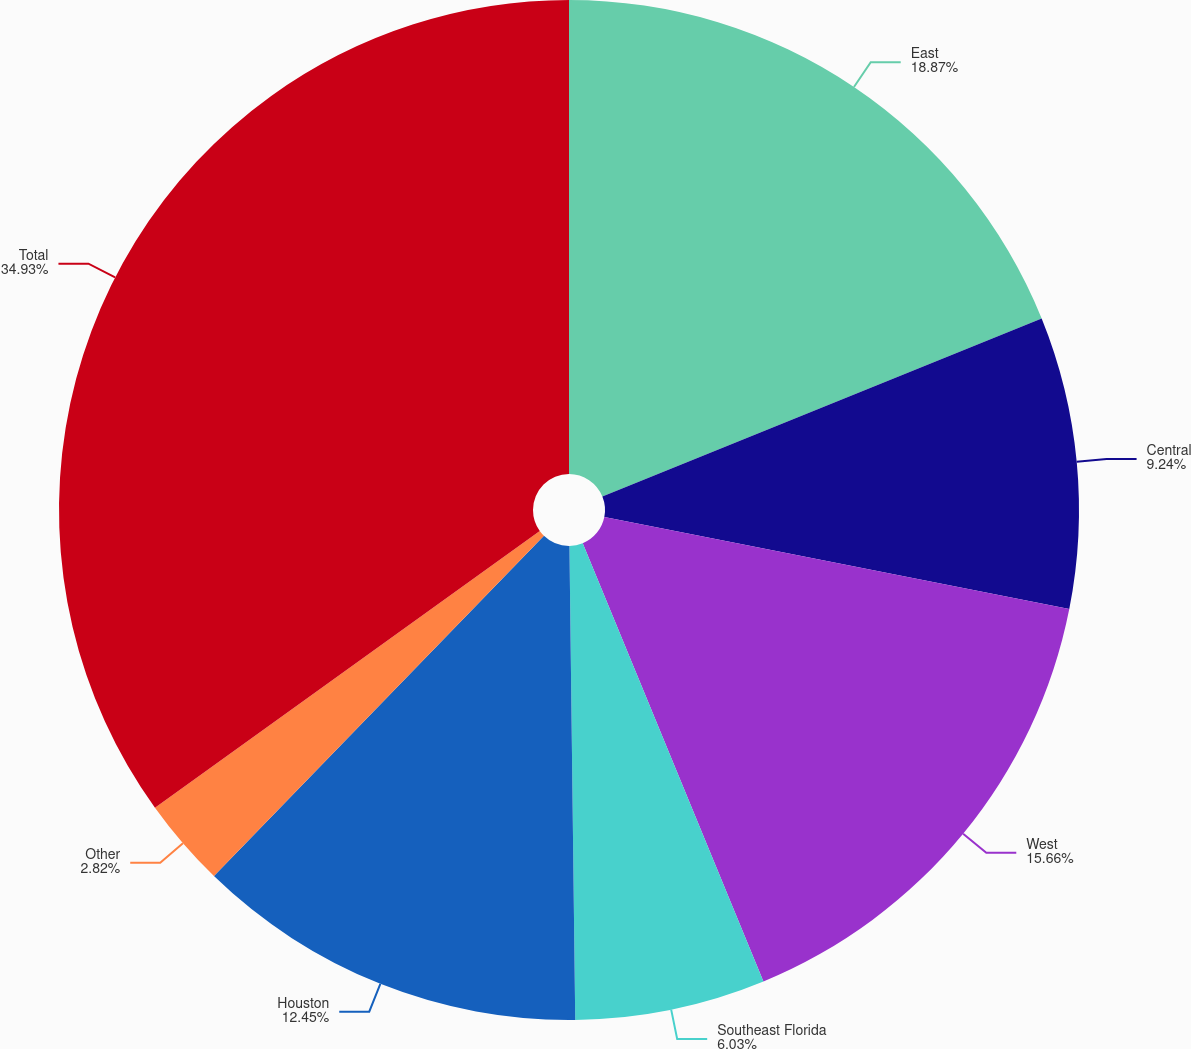<chart> <loc_0><loc_0><loc_500><loc_500><pie_chart><fcel>East<fcel>Central<fcel>West<fcel>Southeast Florida<fcel>Houston<fcel>Other<fcel>Total<nl><fcel>18.87%<fcel>9.24%<fcel>15.66%<fcel>6.03%<fcel>12.45%<fcel>2.82%<fcel>34.92%<nl></chart> 